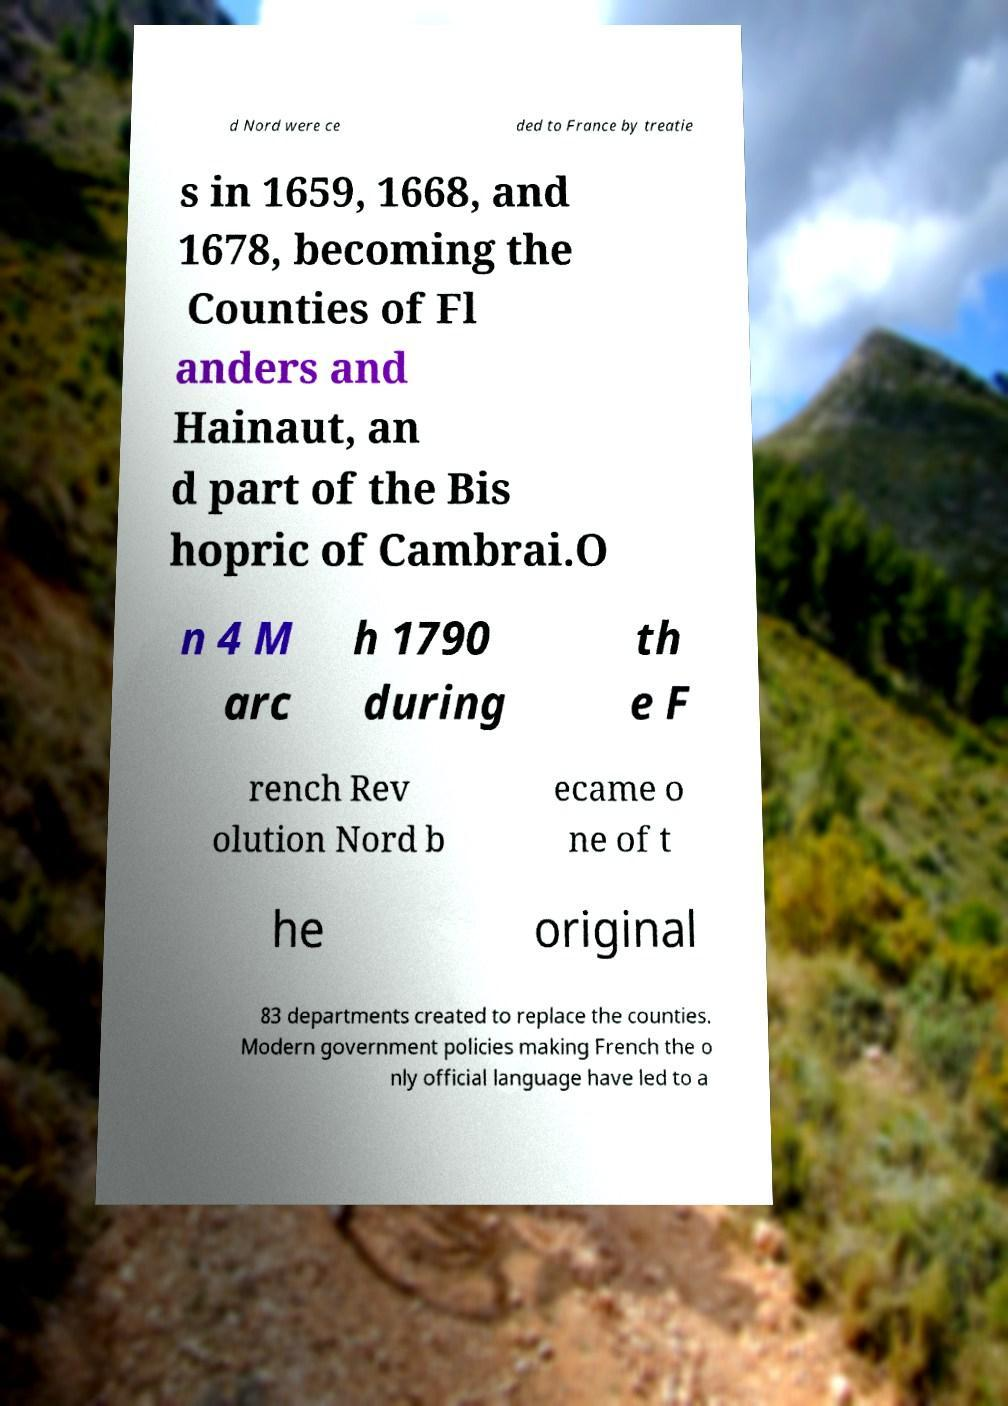There's text embedded in this image that I need extracted. Can you transcribe it verbatim? d Nord were ce ded to France by treatie s in 1659, 1668, and 1678, becoming the Counties of Fl anders and Hainaut, an d part of the Bis hopric of Cambrai.O n 4 M arc h 1790 during th e F rench Rev olution Nord b ecame o ne of t he original 83 departments created to replace the counties. Modern government policies making French the o nly official language have led to a 